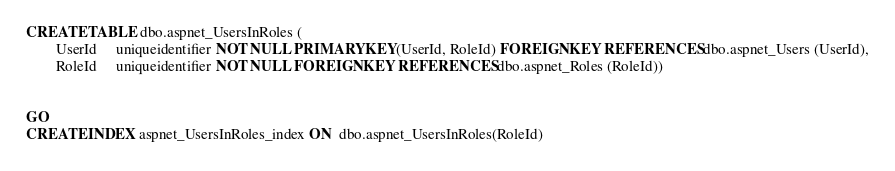Convert code to text. <code><loc_0><loc_0><loc_500><loc_500><_SQL_>CREATE TABLE dbo.aspnet_UsersInRoles (
        UserId     uniqueidentifier NOT NULL PRIMARY KEY(UserId, RoleId) FOREIGN KEY REFERENCES dbo.aspnet_Users (UserId),
        RoleId     uniqueidentifier NOT NULL FOREIGN KEY REFERENCES dbo.aspnet_Roles (RoleId))


GO
CREATE INDEX aspnet_UsersInRoles_index ON  dbo.aspnet_UsersInRoles(RoleId)

</code> 